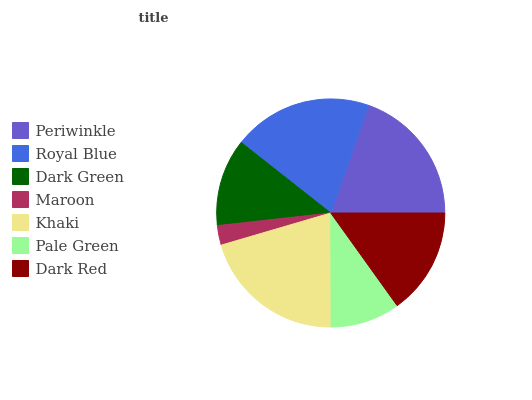Is Maroon the minimum?
Answer yes or no. Yes. Is Khaki the maximum?
Answer yes or no. Yes. Is Royal Blue the minimum?
Answer yes or no. No. Is Royal Blue the maximum?
Answer yes or no. No. Is Royal Blue greater than Periwinkle?
Answer yes or no. Yes. Is Periwinkle less than Royal Blue?
Answer yes or no. Yes. Is Periwinkle greater than Royal Blue?
Answer yes or no. No. Is Royal Blue less than Periwinkle?
Answer yes or no. No. Is Dark Red the high median?
Answer yes or no. Yes. Is Dark Red the low median?
Answer yes or no. Yes. Is Periwinkle the high median?
Answer yes or no. No. Is Pale Green the low median?
Answer yes or no. No. 